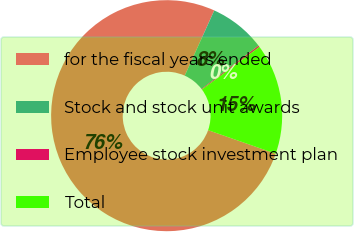Convert chart. <chart><loc_0><loc_0><loc_500><loc_500><pie_chart><fcel>for the fiscal years ended<fcel>Stock and stock unit awards<fcel>Employee stock investment plan<fcel>Total<nl><fcel>76.43%<fcel>7.86%<fcel>0.24%<fcel>15.48%<nl></chart> 